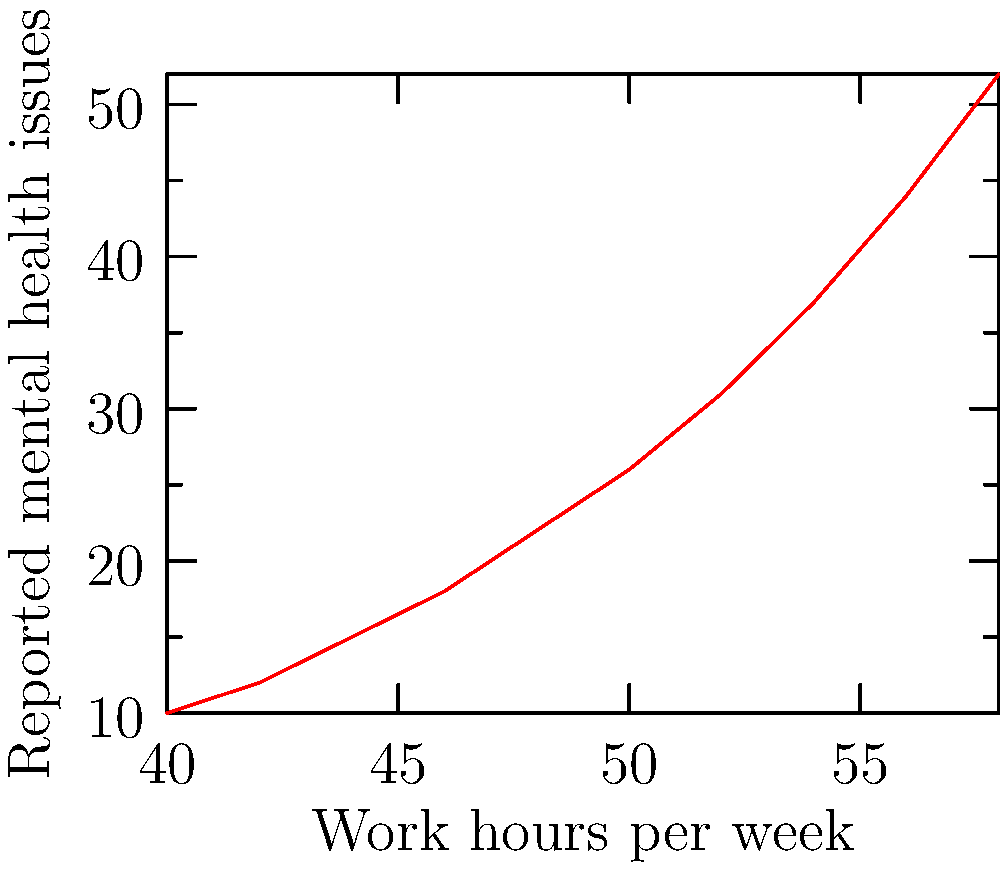Based on the scatter plot showing the relationship between weekly work hours and reported mental health issues among police officers, what type of correlation is observed? To determine the type of correlation in the scatter plot, we need to analyze the pattern of the data points:

1. Direction: As we move from left to right, the data points generally move upward. This indicates a positive relationship between work hours and reported mental health issues.

2. Form: The points roughly follow a curved line, suggesting a non-linear relationship.

3. Strength: The points are relatively close to the imaginary curve, indicating a strong relationship.

4. Consistency: The rate of increase appears to accelerate as work hours increase, suggesting a non-linear pattern.

Given these observations, we can conclude that the scatter plot shows a strong, positive, non-linear correlation between work hours and reported mental health issues among police officers.

The relationship appears to be exponential, as the number of reported mental health issues increases at an accelerating rate as work hours increase.
Answer: Strong positive non-linear (exponential) correlation 